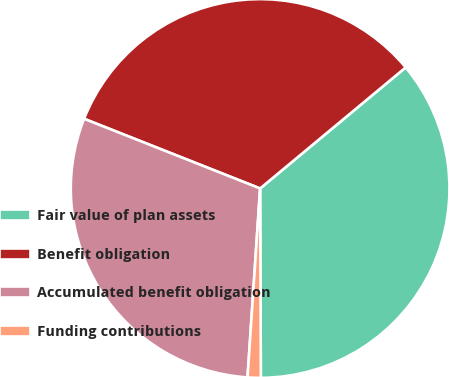Convert chart to OTSL. <chart><loc_0><loc_0><loc_500><loc_500><pie_chart><fcel>Fair value of plan assets<fcel>Benefit obligation<fcel>Accumulated benefit obligation<fcel>Funding contributions<nl><fcel>35.98%<fcel>32.96%<fcel>29.94%<fcel>1.12%<nl></chart> 